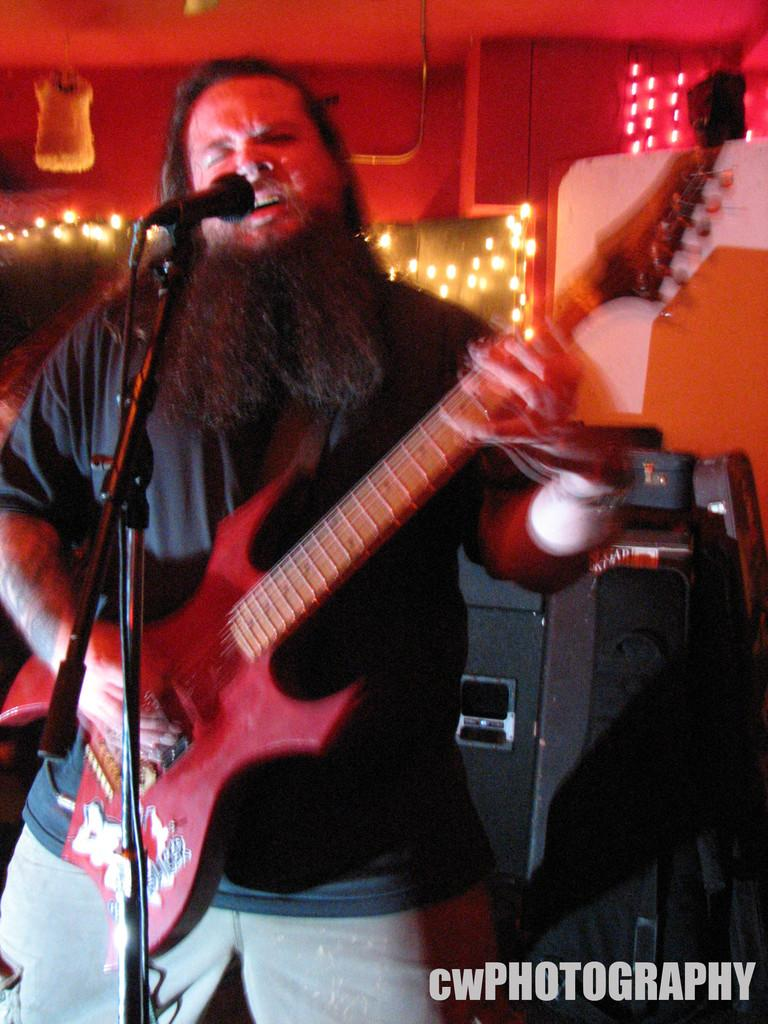What is the person in the image doing? The person is playing a guitar. What is the person wearing in the image? The person is wearing a black T-shirt. What object is in front of the person? There is a microphone in front of the person. What can be seen on the right side of the image? There is a sound box on the right side of the image. What type of shoes is the person wearing in the image? The provided facts do not mention shoes, so we cannot determine the type of shoes the person is wearing. 